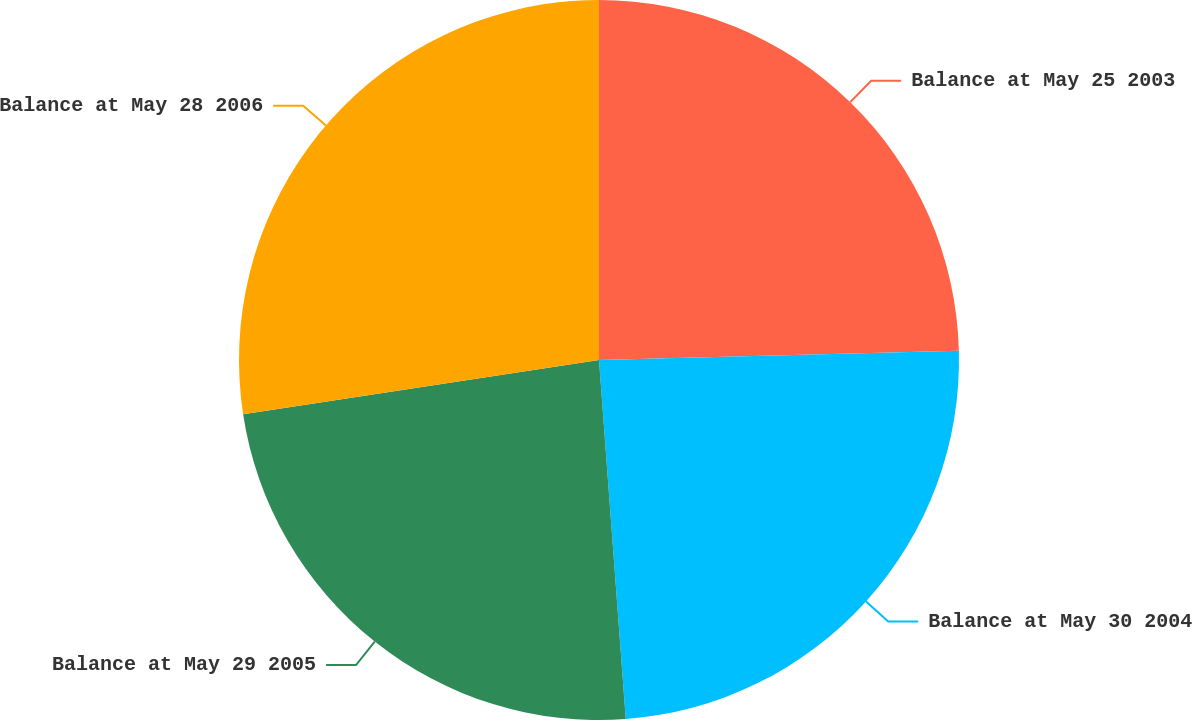Convert chart to OTSL. <chart><loc_0><loc_0><loc_500><loc_500><pie_chart><fcel>Balance at May 25 2003<fcel>Balance at May 30 2004<fcel>Balance at May 29 2005<fcel>Balance at May 28 2006<nl><fcel>24.59%<fcel>24.23%<fcel>23.78%<fcel>27.41%<nl></chart> 